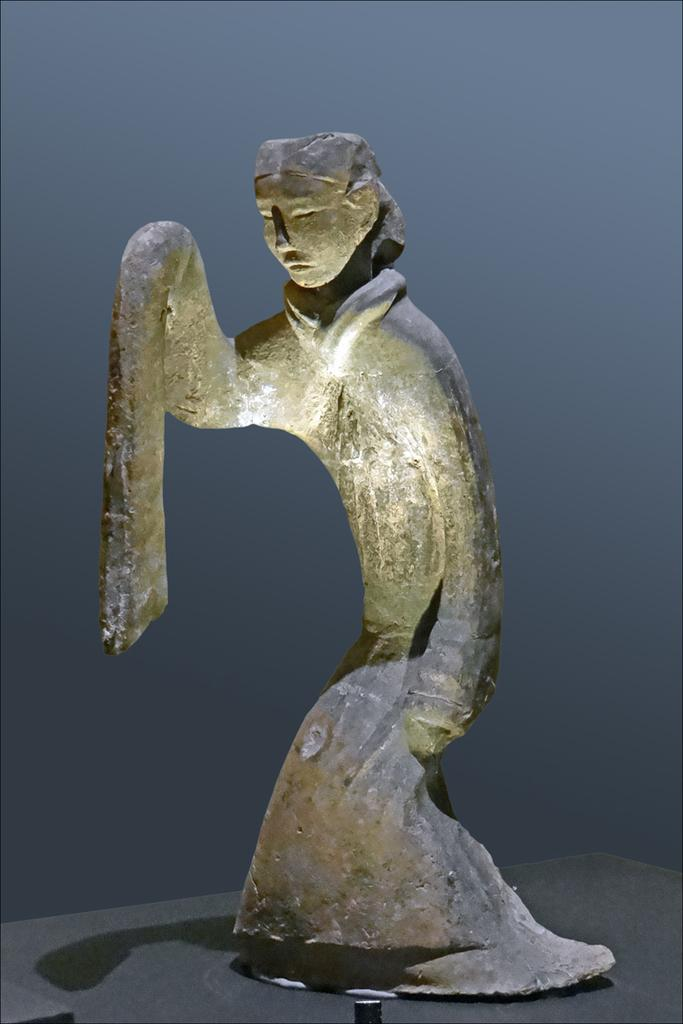What is the main subject in the image? There is a statue in the image. How is the statue positioned in relation to the viewer? The statue is in front of the viewer. What can be seen behind the statue in the image? There is a wall behind the statue in the image. What type of boat is docked near the statue in the image? There is no boat present in the image; it only features a statue and a wall. 